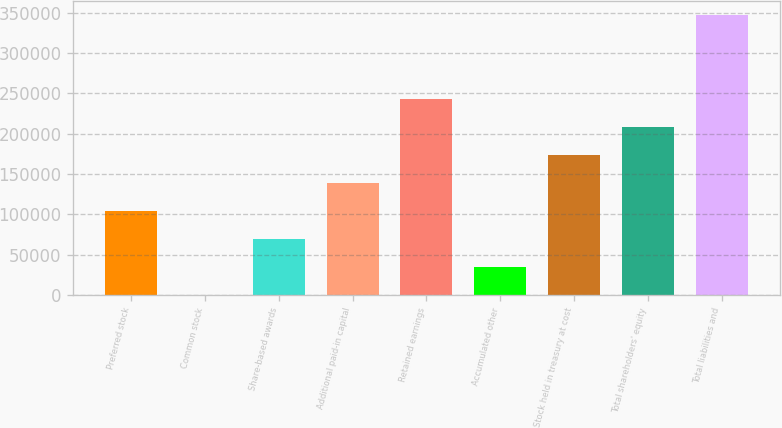Convert chart. <chart><loc_0><loc_0><loc_500><loc_500><bar_chart><fcel>Preferred stock<fcel>Common stock<fcel>Share-based awards<fcel>Additional paid-in capital<fcel>Retained earnings<fcel>Accumulated other<fcel>Stock held in treasury at cost<fcel>Total shareholders' equity<fcel>Total liabilities and<nl><fcel>104056<fcel>9<fcel>69373.8<fcel>138739<fcel>242786<fcel>34691.4<fcel>173421<fcel>208103<fcel>346833<nl></chart> 